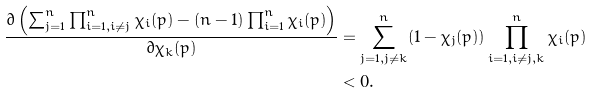<formula> <loc_0><loc_0><loc_500><loc_500>\frac { \partial \left ( \sum _ { j = 1 } ^ { n } \prod _ { i = 1 , i \neq j } ^ { n } \chi _ { i } ( p ) - ( n - 1 ) \prod _ { i = 1 } ^ { n } \chi _ { i } ( p ) \right ) } { \partial \chi _ { k } ( p ) } & = \sum _ { j = 1 , j \neq k } ^ { n } ( 1 - \chi _ { j } ( p ) ) \prod _ { i = 1 , i \neq j , k } ^ { n } \chi _ { i } ( p ) \\ & < 0 .</formula> 